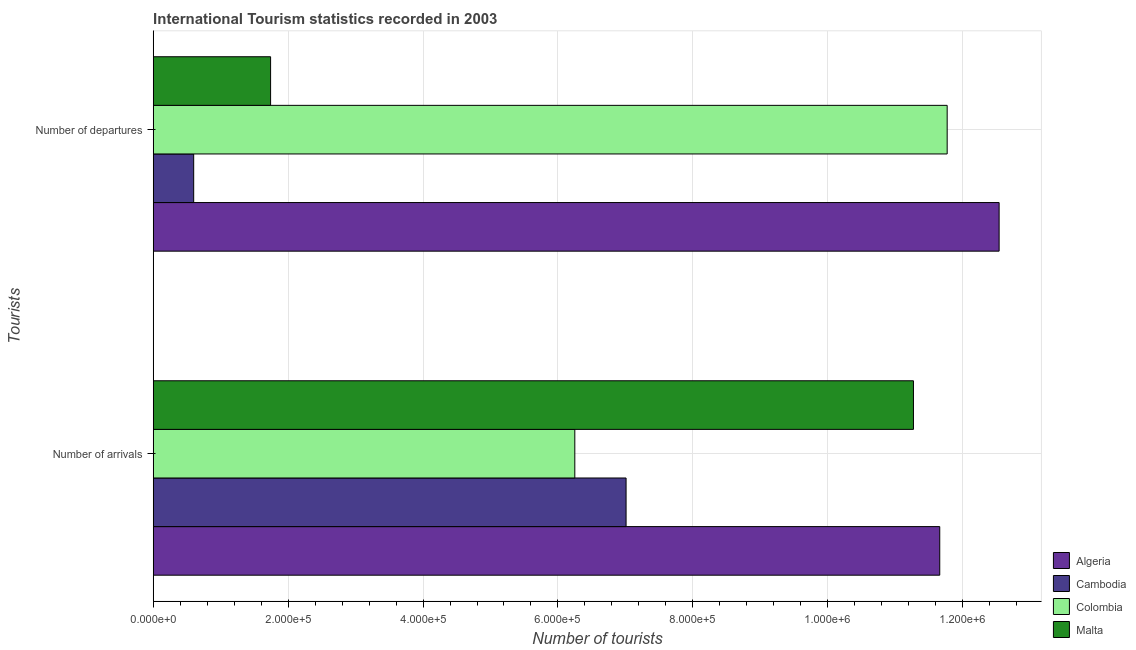How many different coloured bars are there?
Make the answer very short. 4. Are the number of bars on each tick of the Y-axis equal?
Make the answer very short. Yes. What is the label of the 1st group of bars from the top?
Make the answer very short. Number of departures. What is the number of tourist departures in Malta?
Offer a terse response. 1.74e+05. Across all countries, what is the maximum number of tourist departures?
Your response must be concise. 1.25e+06. Across all countries, what is the minimum number of tourist arrivals?
Offer a terse response. 6.25e+05. In which country was the number of tourist departures maximum?
Make the answer very short. Algeria. What is the total number of tourist arrivals in the graph?
Your answer should be compact. 3.62e+06. What is the difference between the number of tourist departures in Colombia and that in Malta?
Give a very brief answer. 1.00e+06. What is the difference between the number of tourist arrivals in Colombia and the number of tourist departures in Algeria?
Your response must be concise. -6.29e+05. What is the average number of tourist arrivals per country?
Keep it short and to the point. 9.05e+05. What is the difference between the number of tourist departures and number of tourist arrivals in Colombia?
Ensure brevity in your answer.  5.52e+05. In how many countries, is the number of tourist departures greater than 920000 ?
Keep it short and to the point. 2. What is the ratio of the number of tourist departures in Algeria to that in Colombia?
Provide a succinct answer. 1.07. Is the number of tourist departures in Cambodia less than that in Malta?
Offer a terse response. Yes. In how many countries, is the number of tourist arrivals greater than the average number of tourist arrivals taken over all countries?
Your response must be concise. 2. What does the 2nd bar from the top in Number of departures represents?
Your answer should be very brief. Colombia. What does the 1st bar from the bottom in Number of arrivals represents?
Provide a succinct answer. Algeria. Are all the bars in the graph horizontal?
Your answer should be compact. Yes. How many countries are there in the graph?
Offer a very short reply. 4. Does the graph contain grids?
Your answer should be very brief. Yes. What is the title of the graph?
Keep it short and to the point. International Tourism statistics recorded in 2003. Does "Kiribati" appear as one of the legend labels in the graph?
Give a very brief answer. No. What is the label or title of the X-axis?
Make the answer very short. Number of tourists. What is the label or title of the Y-axis?
Provide a succinct answer. Tourists. What is the Number of tourists of Algeria in Number of arrivals?
Your answer should be very brief. 1.17e+06. What is the Number of tourists of Cambodia in Number of arrivals?
Ensure brevity in your answer.  7.01e+05. What is the Number of tourists in Colombia in Number of arrivals?
Make the answer very short. 6.25e+05. What is the Number of tourists in Malta in Number of arrivals?
Your answer should be compact. 1.13e+06. What is the Number of tourists of Algeria in Number of departures?
Provide a succinct answer. 1.25e+06. What is the Number of tourists of Colombia in Number of departures?
Keep it short and to the point. 1.18e+06. What is the Number of tourists in Malta in Number of departures?
Your answer should be compact. 1.74e+05. Across all Tourists, what is the maximum Number of tourists in Algeria?
Provide a short and direct response. 1.25e+06. Across all Tourists, what is the maximum Number of tourists in Cambodia?
Make the answer very short. 7.01e+05. Across all Tourists, what is the maximum Number of tourists in Colombia?
Ensure brevity in your answer.  1.18e+06. Across all Tourists, what is the maximum Number of tourists of Malta?
Provide a short and direct response. 1.13e+06. Across all Tourists, what is the minimum Number of tourists in Algeria?
Provide a short and direct response. 1.17e+06. Across all Tourists, what is the minimum Number of tourists of Colombia?
Your response must be concise. 6.25e+05. Across all Tourists, what is the minimum Number of tourists in Malta?
Your answer should be very brief. 1.74e+05. What is the total Number of tourists of Algeria in the graph?
Your answer should be compact. 2.42e+06. What is the total Number of tourists of Cambodia in the graph?
Offer a very short reply. 7.61e+05. What is the total Number of tourists of Colombia in the graph?
Your answer should be very brief. 1.80e+06. What is the total Number of tourists of Malta in the graph?
Your response must be concise. 1.30e+06. What is the difference between the Number of tourists of Algeria in Number of arrivals and that in Number of departures?
Keep it short and to the point. -8.80e+04. What is the difference between the Number of tourists of Cambodia in Number of arrivals and that in Number of departures?
Keep it short and to the point. 6.41e+05. What is the difference between the Number of tourists in Colombia in Number of arrivals and that in Number of departures?
Provide a short and direct response. -5.52e+05. What is the difference between the Number of tourists of Malta in Number of arrivals and that in Number of departures?
Your response must be concise. 9.53e+05. What is the difference between the Number of tourists of Algeria in Number of arrivals and the Number of tourists of Cambodia in Number of departures?
Provide a short and direct response. 1.11e+06. What is the difference between the Number of tourists in Algeria in Number of arrivals and the Number of tourists in Colombia in Number of departures?
Ensure brevity in your answer.  -1.10e+04. What is the difference between the Number of tourists of Algeria in Number of arrivals and the Number of tourists of Malta in Number of departures?
Offer a terse response. 9.92e+05. What is the difference between the Number of tourists in Cambodia in Number of arrivals and the Number of tourists in Colombia in Number of departures?
Provide a short and direct response. -4.76e+05. What is the difference between the Number of tourists in Cambodia in Number of arrivals and the Number of tourists in Malta in Number of departures?
Your response must be concise. 5.27e+05. What is the difference between the Number of tourists of Colombia in Number of arrivals and the Number of tourists of Malta in Number of departures?
Offer a very short reply. 4.51e+05. What is the average Number of tourists in Algeria per Tourists?
Offer a terse response. 1.21e+06. What is the average Number of tourists of Cambodia per Tourists?
Make the answer very short. 3.80e+05. What is the average Number of tourists in Colombia per Tourists?
Your answer should be compact. 9.01e+05. What is the average Number of tourists in Malta per Tourists?
Provide a short and direct response. 6.50e+05. What is the difference between the Number of tourists of Algeria and Number of tourists of Cambodia in Number of arrivals?
Your answer should be compact. 4.65e+05. What is the difference between the Number of tourists in Algeria and Number of tourists in Colombia in Number of arrivals?
Ensure brevity in your answer.  5.41e+05. What is the difference between the Number of tourists in Algeria and Number of tourists in Malta in Number of arrivals?
Make the answer very short. 3.90e+04. What is the difference between the Number of tourists in Cambodia and Number of tourists in Colombia in Number of arrivals?
Keep it short and to the point. 7.60e+04. What is the difference between the Number of tourists of Cambodia and Number of tourists of Malta in Number of arrivals?
Provide a succinct answer. -4.26e+05. What is the difference between the Number of tourists of Colombia and Number of tourists of Malta in Number of arrivals?
Ensure brevity in your answer.  -5.02e+05. What is the difference between the Number of tourists of Algeria and Number of tourists of Cambodia in Number of departures?
Offer a terse response. 1.19e+06. What is the difference between the Number of tourists in Algeria and Number of tourists in Colombia in Number of departures?
Ensure brevity in your answer.  7.70e+04. What is the difference between the Number of tourists of Algeria and Number of tourists of Malta in Number of departures?
Provide a short and direct response. 1.08e+06. What is the difference between the Number of tourists in Cambodia and Number of tourists in Colombia in Number of departures?
Make the answer very short. -1.12e+06. What is the difference between the Number of tourists in Cambodia and Number of tourists in Malta in Number of departures?
Your answer should be compact. -1.14e+05. What is the difference between the Number of tourists of Colombia and Number of tourists of Malta in Number of departures?
Your response must be concise. 1.00e+06. What is the ratio of the Number of tourists in Algeria in Number of arrivals to that in Number of departures?
Your answer should be very brief. 0.93. What is the ratio of the Number of tourists in Cambodia in Number of arrivals to that in Number of departures?
Your answer should be very brief. 11.68. What is the ratio of the Number of tourists of Colombia in Number of arrivals to that in Number of departures?
Your answer should be compact. 0.53. What is the ratio of the Number of tourists of Malta in Number of arrivals to that in Number of departures?
Make the answer very short. 6.48. What is the difference between the highest and the second highest Number of tourists of Algeria?
Provide a short and direct response. 8.80e+04. What is the difference between the highest and the second highest Number of tourists in Cambodia?
Provide a short and direct response. 6.41e+05. What is the difference between the highest and the second highest Number of tourists in Colombia?
Give a very brief answer. 5.52e+05. What is the difference between the highest and the second highest Number of tourists of Malta?
Offer a terse response. 9.53e+05. What is the difference between the highest and the lowest Number of tourists of Algeria?
Offer a very short reply. 8.80e+04. What is the difference between the highest and the lowest Number of tourists in Cambodia?
Your answer should be very brief. 6.41e+05. What is the difference between the highest and the lowest Number of tourists of Colombia?
Your answer should be very brief. 5.52e+05. What is the difference between the highest and the lowest Number of tourists of Malta?
Offer a very short reply. 9.53e+05. 